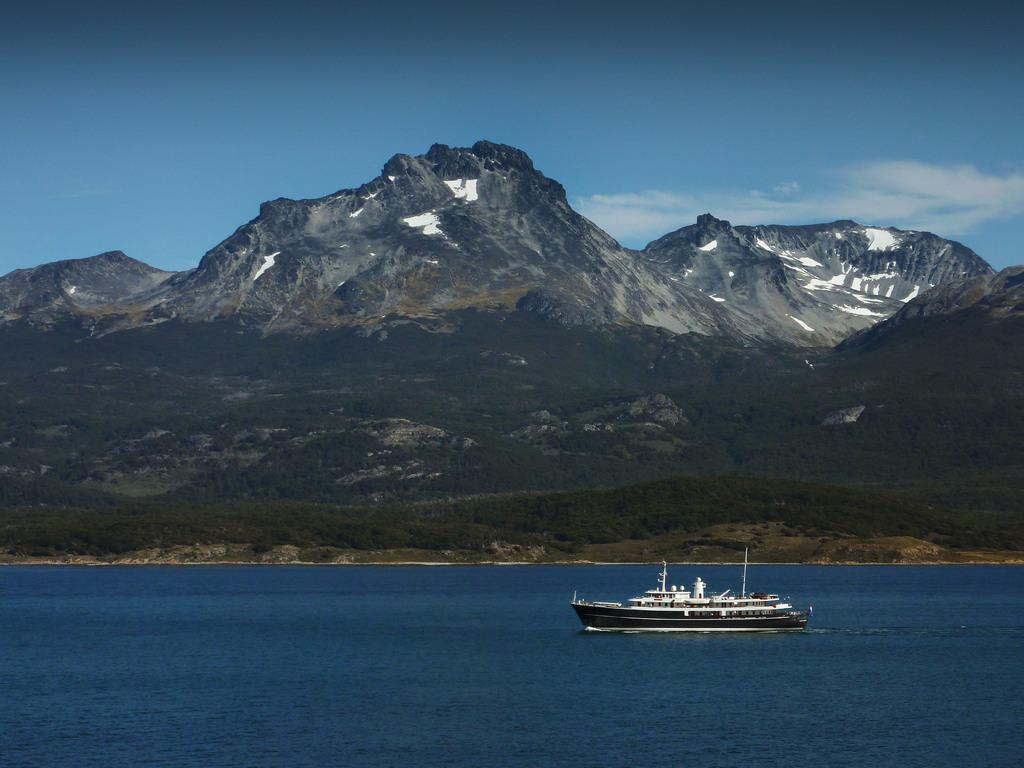What is the main subject of the image? The main subject of the image is a ship sailing on the water. What is the ship sailing on? The ship is sailing on water. What type of landscape can be seen in the image? There is grass and hills visible in the image. What is visible in the sky? The sky is visible in the image, and clouds are present. What type of shock does the grandfather experience in the image? There is no grandfather or any indication of a shock in the image. 